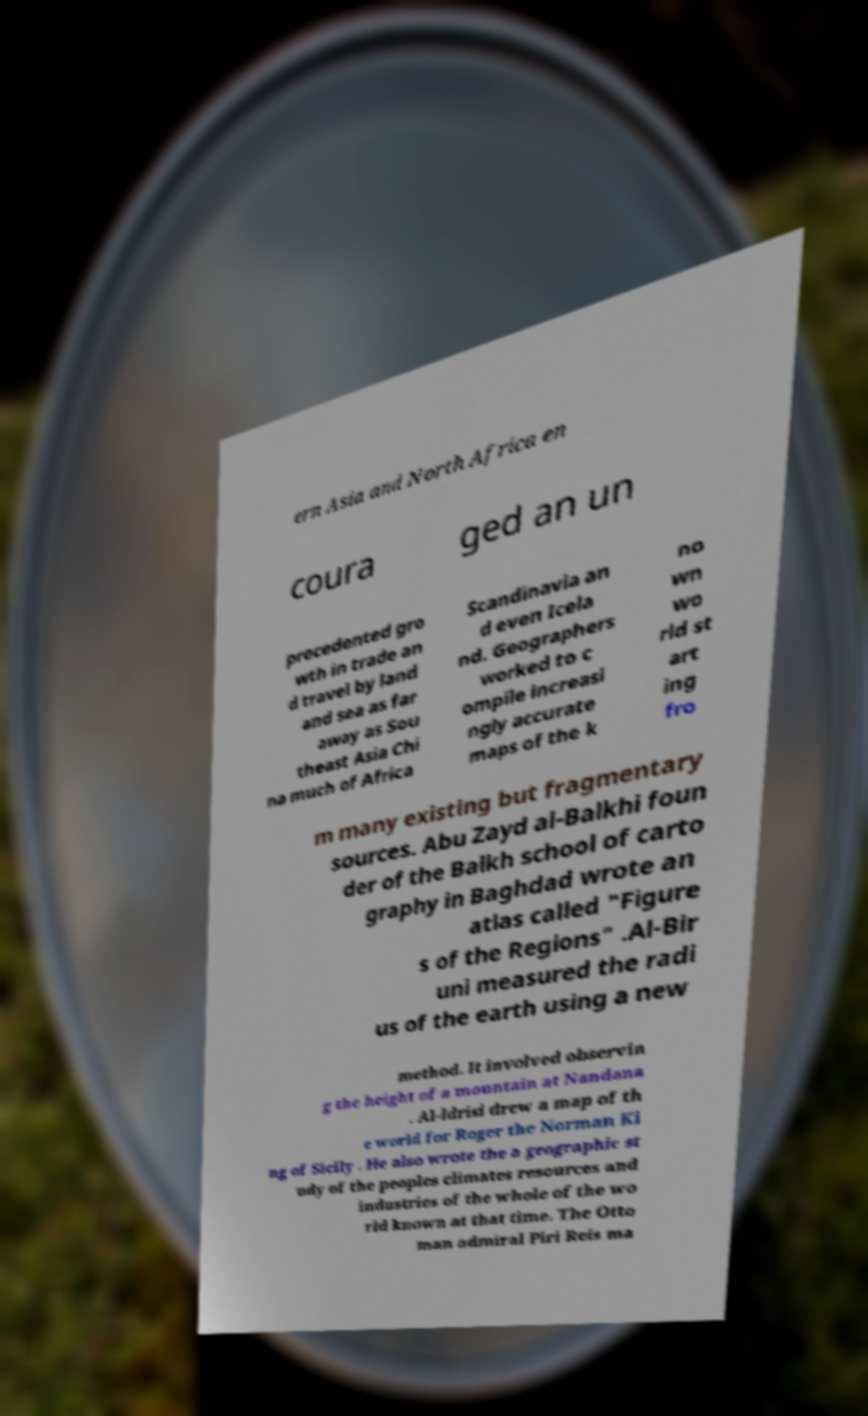Can you accurately transcribe the text from the provided image for me? ern Asia and North Africa en coura ged an un precedented gro wth in trade an d travel by land and sea as far away as Sou theast Asia Chi na much of Africa Scandinavia an d even Icela nd. Geographers worked to c ompile increasi ngly accurate maps of the k no wn wo rld st art ing fro m many existing but fragmentary sources. Abu Zayd al-Balkhi foun der of the Balkh school of carto graphy in Baghdad wrote an atlas called "Figure s of the Regions" .Al-Bir uni measured the radi us of the earth using a new method. It involved observin g the height of a mountain at Nandana . Al-Idrisi drew a map of th e world for Roger the Norman Ki ng of Sicily . He also wrote the a geographic st udy of the peoples climates resources and industries of the whole of the wo rld known at that time. The Otto man admiral Piri Reis ma 